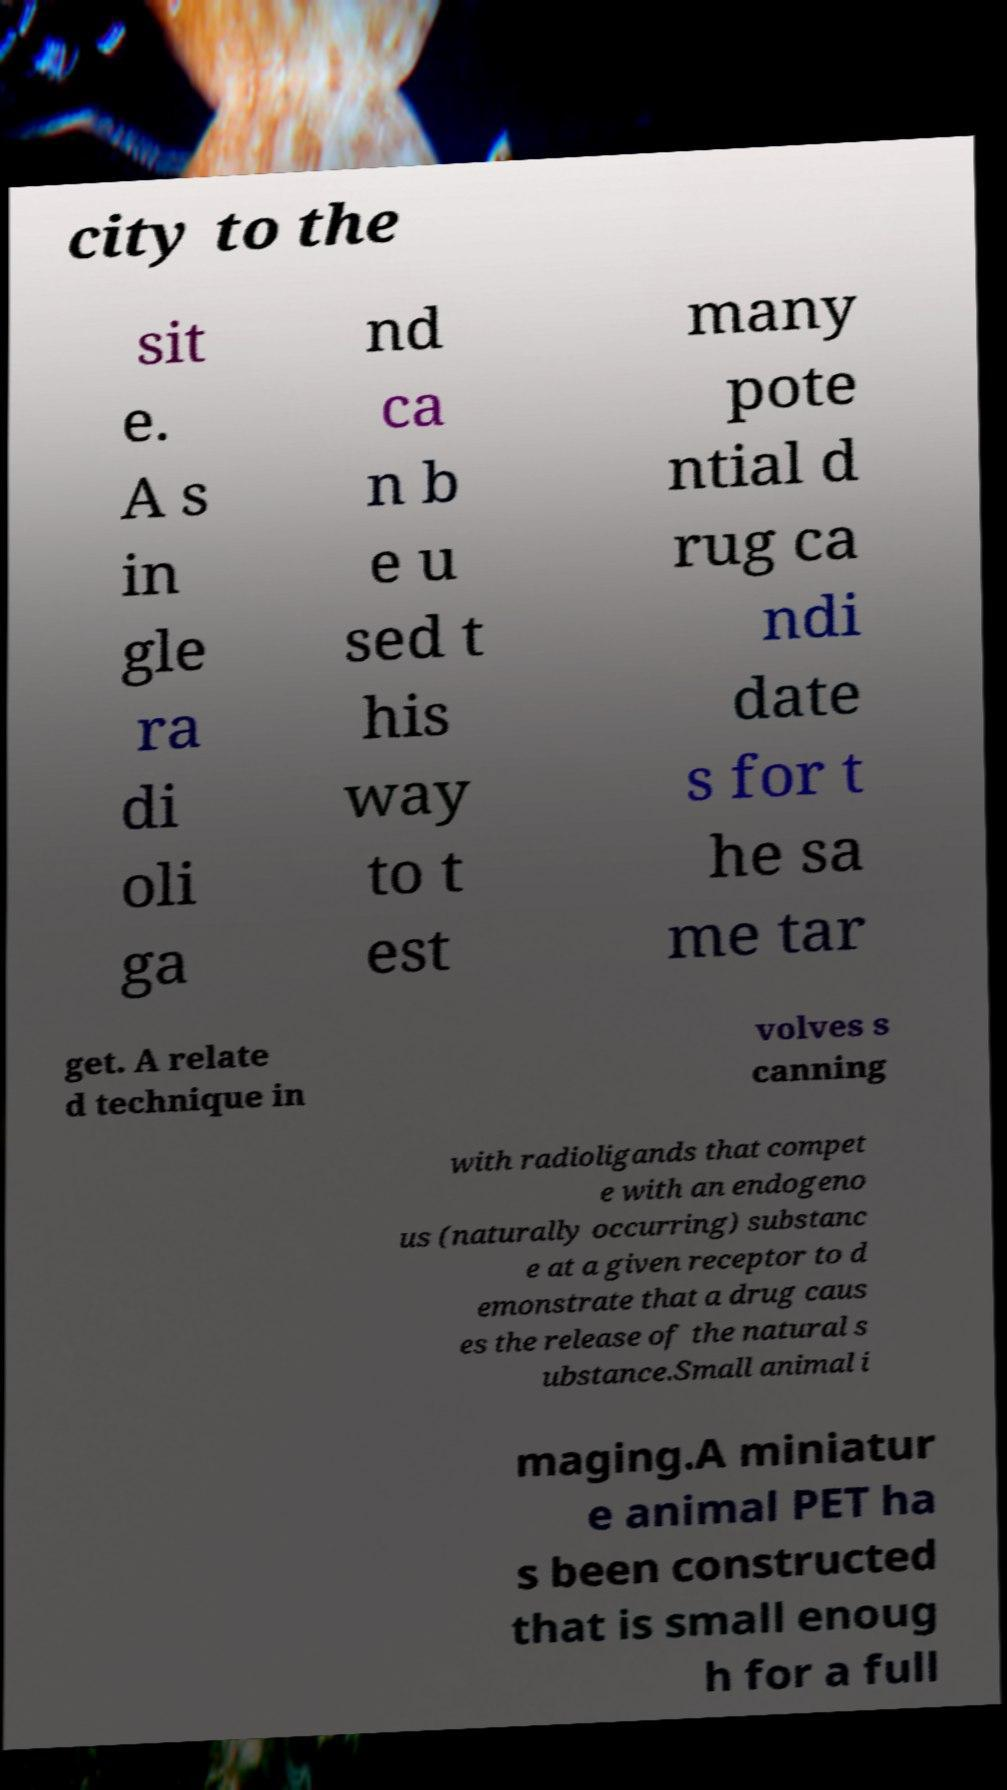Please read and relay the text visible in this image. What does it say? city to the sit e. A s in gle ra di oli ga nd ca n b e u sed t his way to t est many pote ntial d rug ca ndi date s for t he sa me tar get. A relate d technique in volves s canning with radioligands that compet e with an endogeno us (naturally occurring) substanc e at a given receptor to d emonstrate that a drug caus es the release of the natural s ubstance.Small animal i maging.A miniatur e animal PET ha s been constructed that is small enoug h for a full 